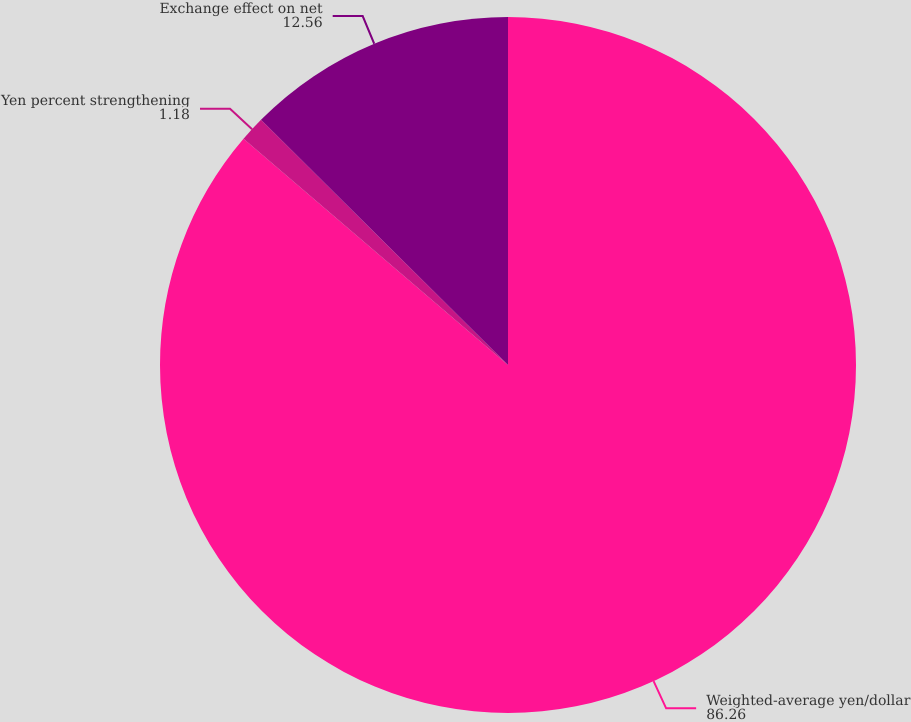Convert chart to OTSL. <chart><loc_0><loc_0><loc_500><loc_500><pie_chart><fcel>Weighted-average yen/dollar<fcel>Yen percent strengthening<fcel>Exchange effect on net<nl><fcel>86.26%<fcel>1.18%<fcel>12.56%<nl></chart> 